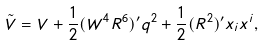Convert formula to latex. <formula><loc_0><loc_0><loc_500><loc_500>\tilde { V } = V + \frac { 1 } { 2 } ( W ^ { 4 } R ^ { 6 } ) ^ { \prime } q ^ { 2 } + \frac { 1 } { 2 } ( R ^ { 2 } ) ^ { \prime } x _ { i } x ^ { i } ,</formula> 